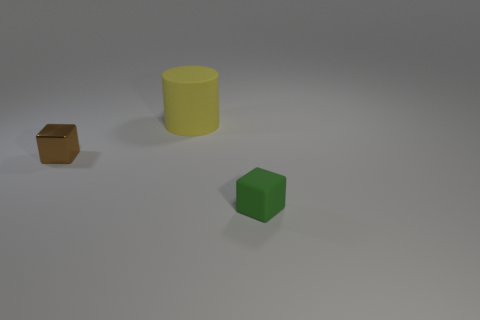Add 2 big gray rubber balls. How many objects exist? 5 Subtract all blocks. How many objects are left? 1 Add 3 large matte cylinders. How many large matte cylinders are left? 4 Add 2 cubes. How many cubes exist? 4 Subtract 0 brown cylinders. How many objects are left? 3 Subtract all big rubber things. Subtract all small green rubber blocks. How many objects are left? 1 